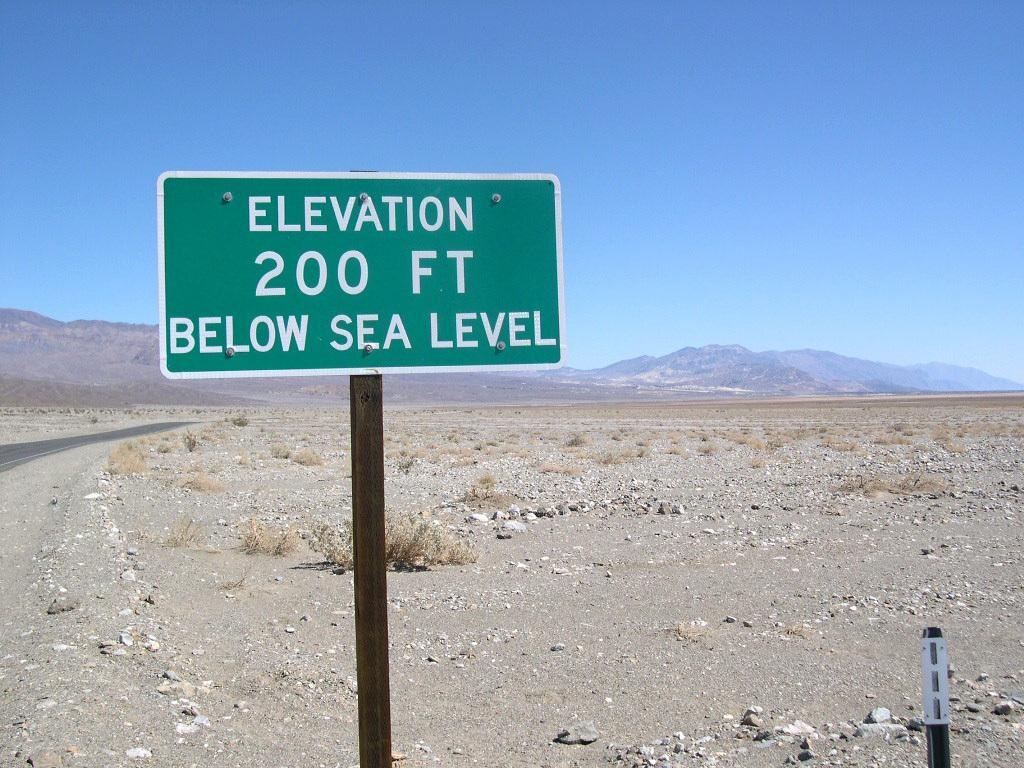<image>
Present a compact description of the photo's key features. A green sign states that the elevation is 200 feet below sea level. 